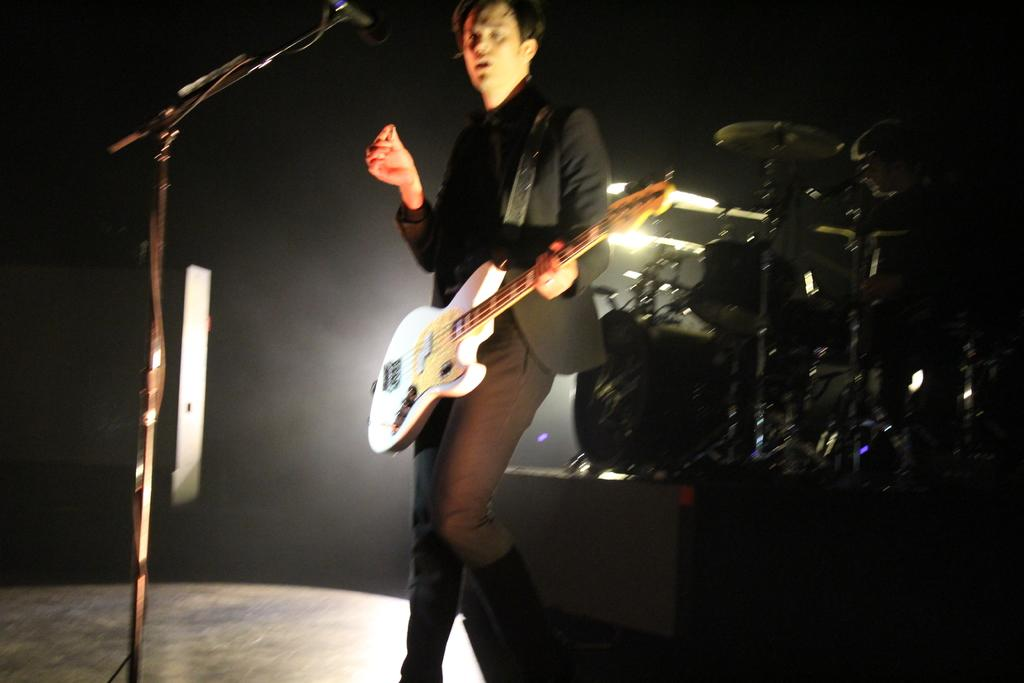What is the man in the center of the image doing? The man is standing in the center of the image and holding a guitar. What object is in front of the man? There is a microphone in front of the man. What can be seen in the background of the image? There is a wall, lights, and musical instruments in the background of the image. What type of bone can be seen in the image? There is no bone present in the image. How many ducks are visible in the image? There are no ducks present in the image. 